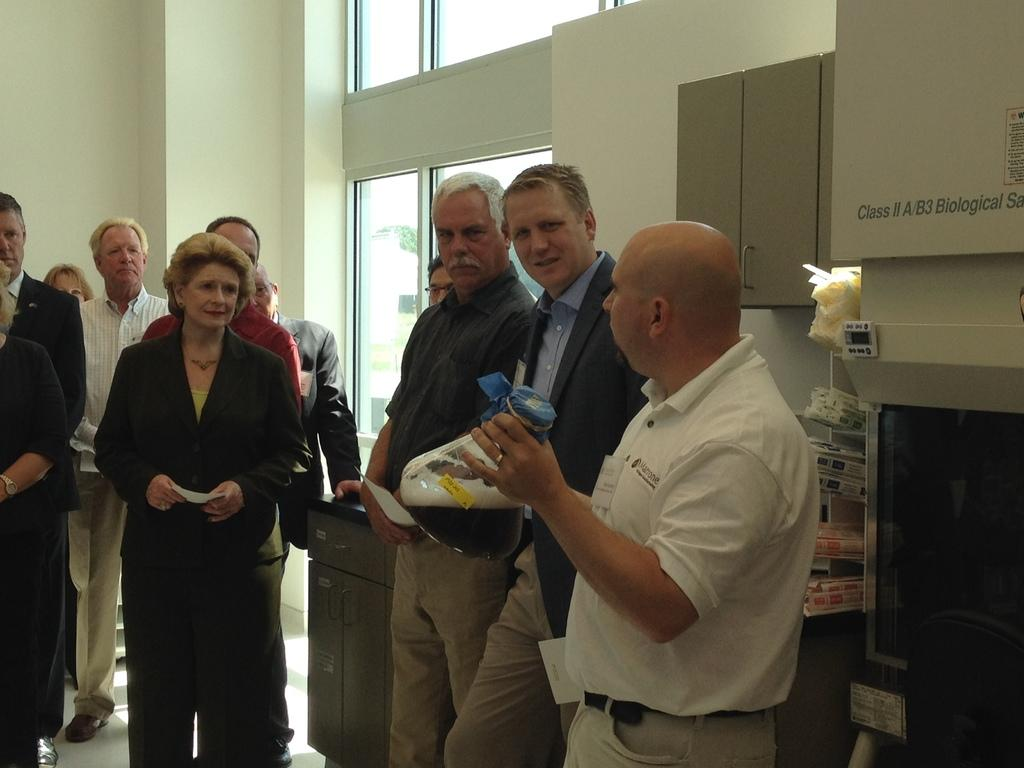What are the people in the image wearing? The people in the image are wearing blazers, shirts, and ties. What can be seen in the background of the image? There is a wall and a glass window in the background of the image. What type of grass can be seen growing on the wall in the image? There is no grass visible in the image; the background features a wall with a glass window. 